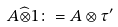<formula> <loc_0><loc_0><loc_500><loc_500>A \widehat { \otimes } 1 \colon = A \otimes \tau ^ { \prime }</formula> 